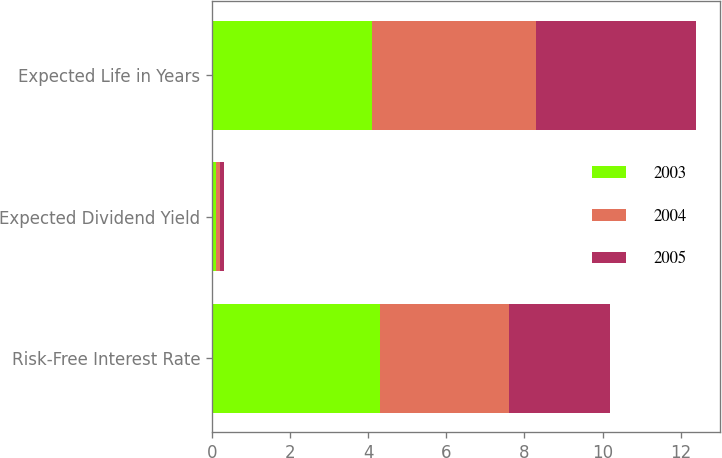Convert chart. <chart><loc_0><loc_0><loc_500><loc_500><stacked_bar_chart><ecel><fcel>Risk-Free Interest Rate<fcel>Expected Dividend Yield<fcel>Expected Life in Years<nl><fcel>2003<fcel>4.3<fcel>0.1<fcel>4.1<nl><fcel>2004<fcel>3.3<fcel>0.1<fcel>4.2<nl><fcel>2005<fcel>2.6<fcel>0.1<fcel>4.1<nl></chart> 